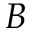<formula> <loc_0><loc_0><loc_500><loc_500>B</formula> 